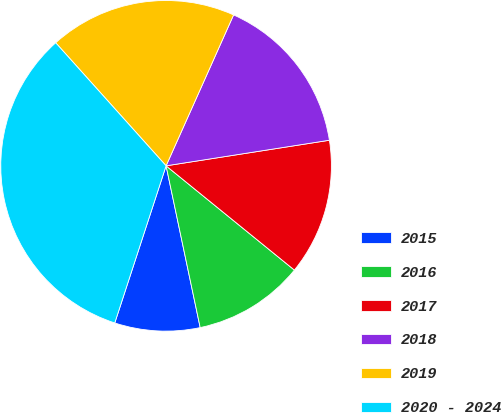<chart> <loc_0><loc_0><loc_500><loc_500><pie_chart><fcel>2015<fcel>2016<fcel>2017<fcel>2018<fcel>2019<fcel>2020 - 2024<nl><fcel>8.33%<fcel>10.83%<fcel>13.33%<fcel>15.83%<fcel>18.33%<fcel>33.33%<nl></chart> 